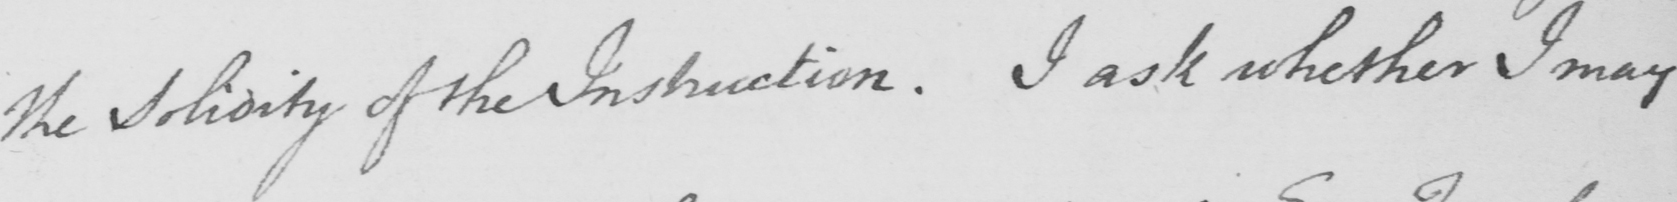Can you tell me what this handwritten text says? the Solidity of the Instruction . I ask whether I may 